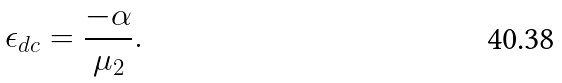Convert formula to latex. <formula><loc_0><loc_0><loc_500><loc_500>\epsilon _ { d c } = \frac { - \alpha } { \mu _ { 2 } } .</formula> 